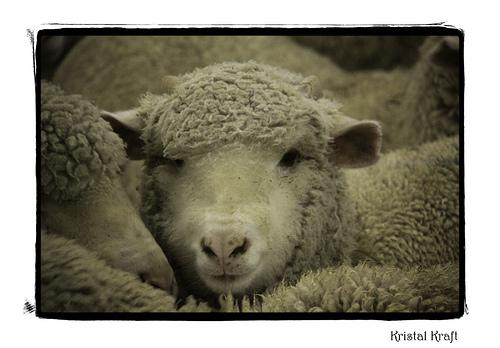What sound will he make? Please explain your reasoning. baa. Sheeps say baa. 